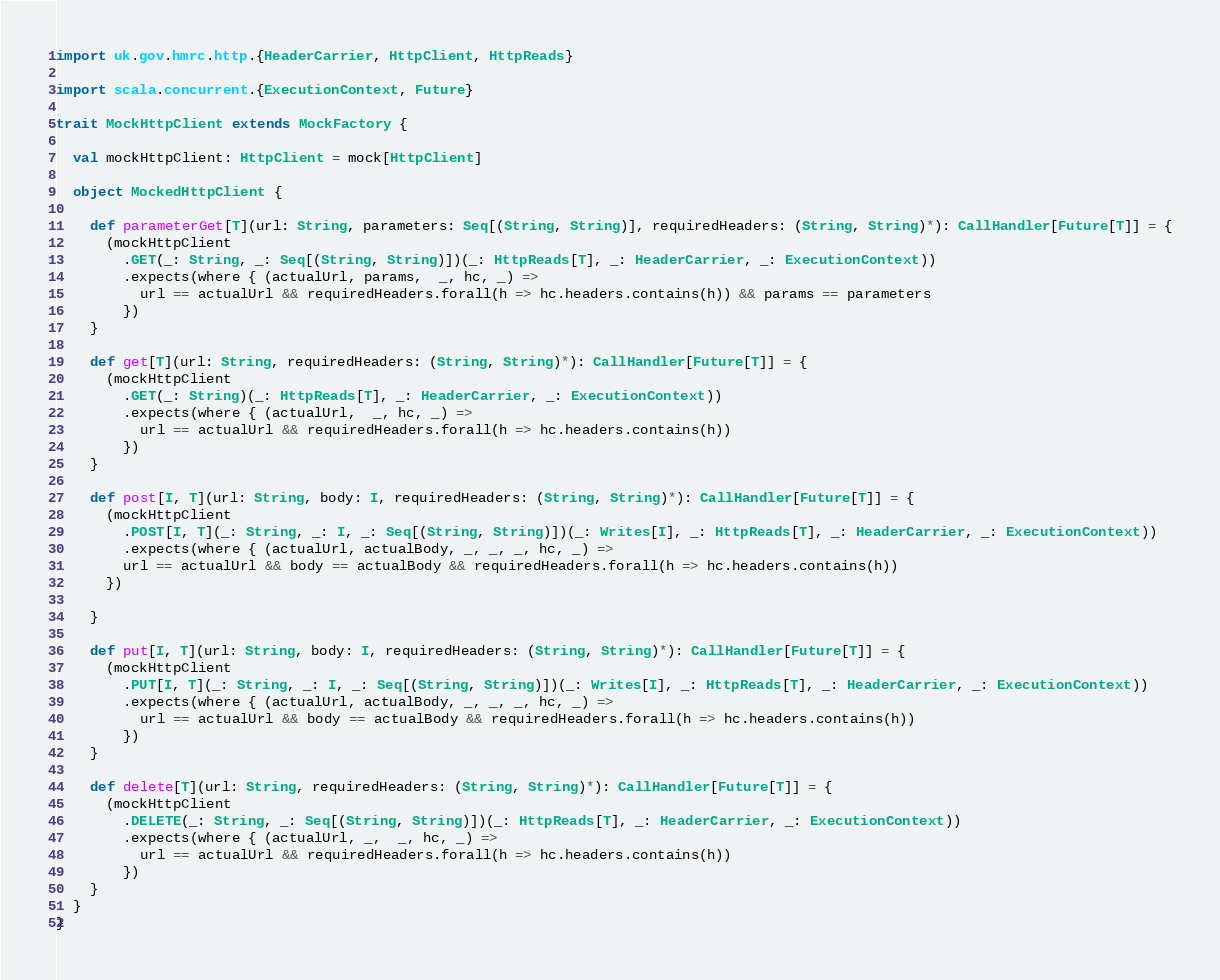Convert code to text. <code><loc_0><loc_0><loc_500><loc_500><_Scala_>import uk.gov.hmrc.http.{HeaderCarrier, HttpClient, HttpReads}

import scala.concurrent.{ExecutionContext, Future}

trait MockHttpClient extends MockFactory {

  val mockHttpClient: HttpClient = mock[HttpClient]

  object MockedHttpClient {

    def parameterGet[T](url: String, parameters: Seq[(String, String)], requiredHeaders: (String, String)*): CallHandler[Future[T]] = {
      (mockHttpClient
        .GET(_: String, _: Seq[(String, String)])(_: HttpReads[T], _: HeaderCarrier, _: ExecutionContext))
        .expects(where { (actualUrl, params,  _, hc, _) =>
          url == actualUrl && requiredHeaders.forall(h => hc.headers.contains(h)) && params == parameters
        })
    }

    def get[T](url: String, requiredHeaders: (String, String)*): CallHandler[Future[T]] = {
      (mockHttpClient
        .GET(_: String)(_: HttpReads[T], _: HeaderCarrier, _: ExecutionContext))
        .expects(where { (actualUrl,  _, hc, _) =>
          url == actualUrl && requiredHeaders.forall(h => hc.headers.contains(h))
        })
    }

    def post[I, T](url: String, body: I, requiredHeaders: (String, String)*): CallHandler[Future[T]] = {
      (mockHttpClient
        .POST[I, T](_: String, _: I, _: Seq[(String, String)])(_: Writes[I], _: HttpReads[T], _: HeaderCarrier, _: ExecutionContext))
        .expects(where { (actualUrl, actualBody, _, _, _, hc, _) =>
        url == actualUrl && body == actualBody && requiredHeaders.forall(h => hc.headers.contains(h))
      })

    }

    def put[I, T](url: String, body: I, requiredHeaders: (String, String)*): CallHandler[Future[T]] = {
      (mockHttpClient
        .PUT[I, T](_: String, _: I, _: Seq[(String, String)])(_: Writes[I], _: HttpReads[T], _: HeaderCarrier, _: ExecutionContext))
        .expects(where { (actualUrl, actualBody, _, _, _, hc, _) =>
          url == actualUrl && body == actualBody && requiredHeaders.forall(h => hc.headers.contains(h))
        })
    }

    def delete[T](url: String, requiredHeaders: (String, String)*): CallHandler[Future[T]] = {
      (mockHttpClient
        .DELETE(_: String, _: Seq[(String, String)])(_: HttpReads[T], _: HeaderCarrier, _: ExecutionContext))
        .expects(where { (actualUrl, _,  _, hc, _) =>
          url == actualUrl && requiredHeaders.forall(h => hc.headers.contains(h))
        })
    }
  }
}
</code> 